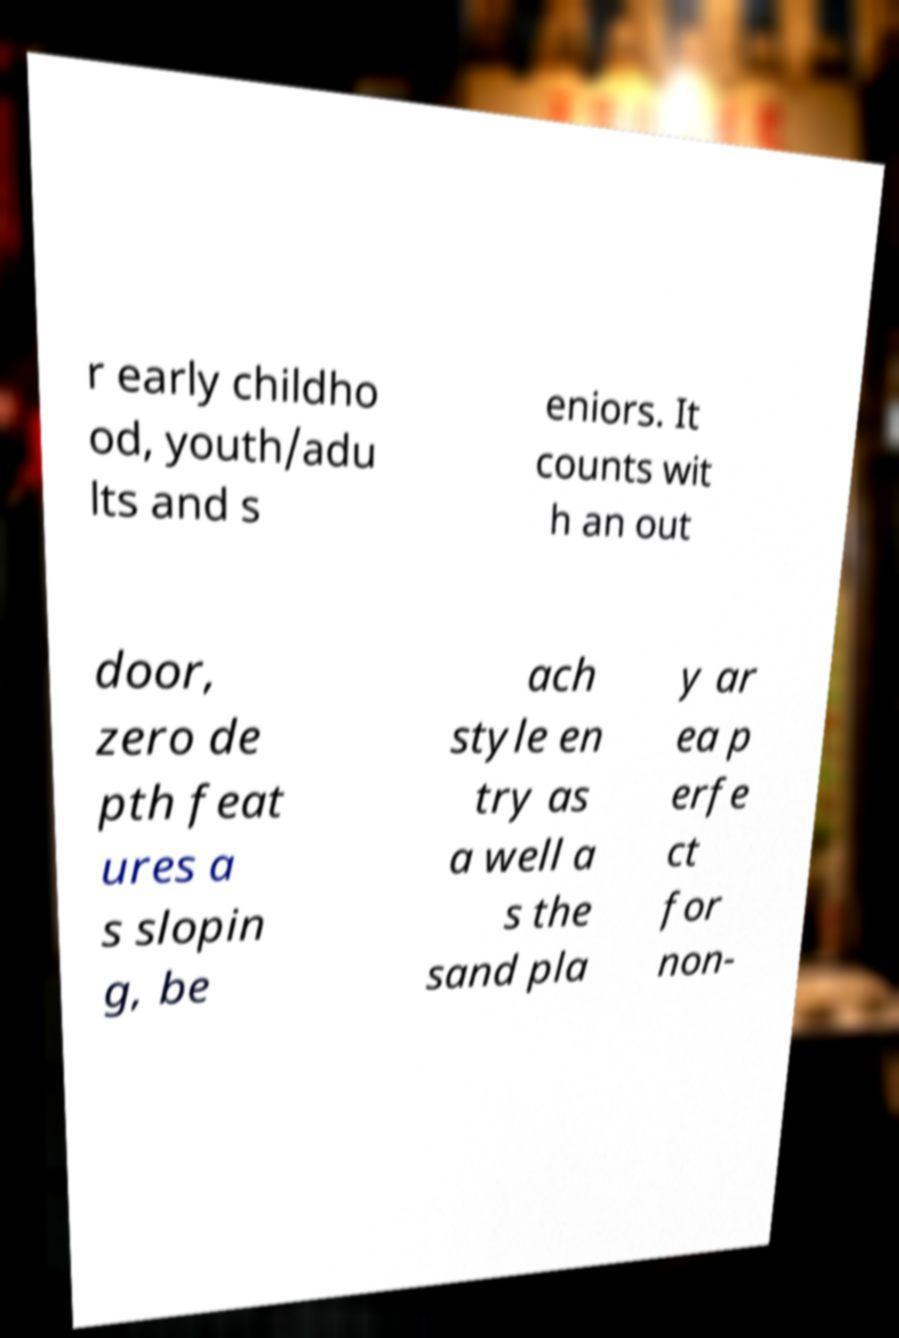For documentation purposes, I need the text within this image transcribed. Could you provide that? r early childho od, youth/adu lts and s eniors. It counts wit h an out door, zero de pth feat ures a s slopin g, be ach style en try as a well a s the sand pla y ar ea p erfe ct for non- 